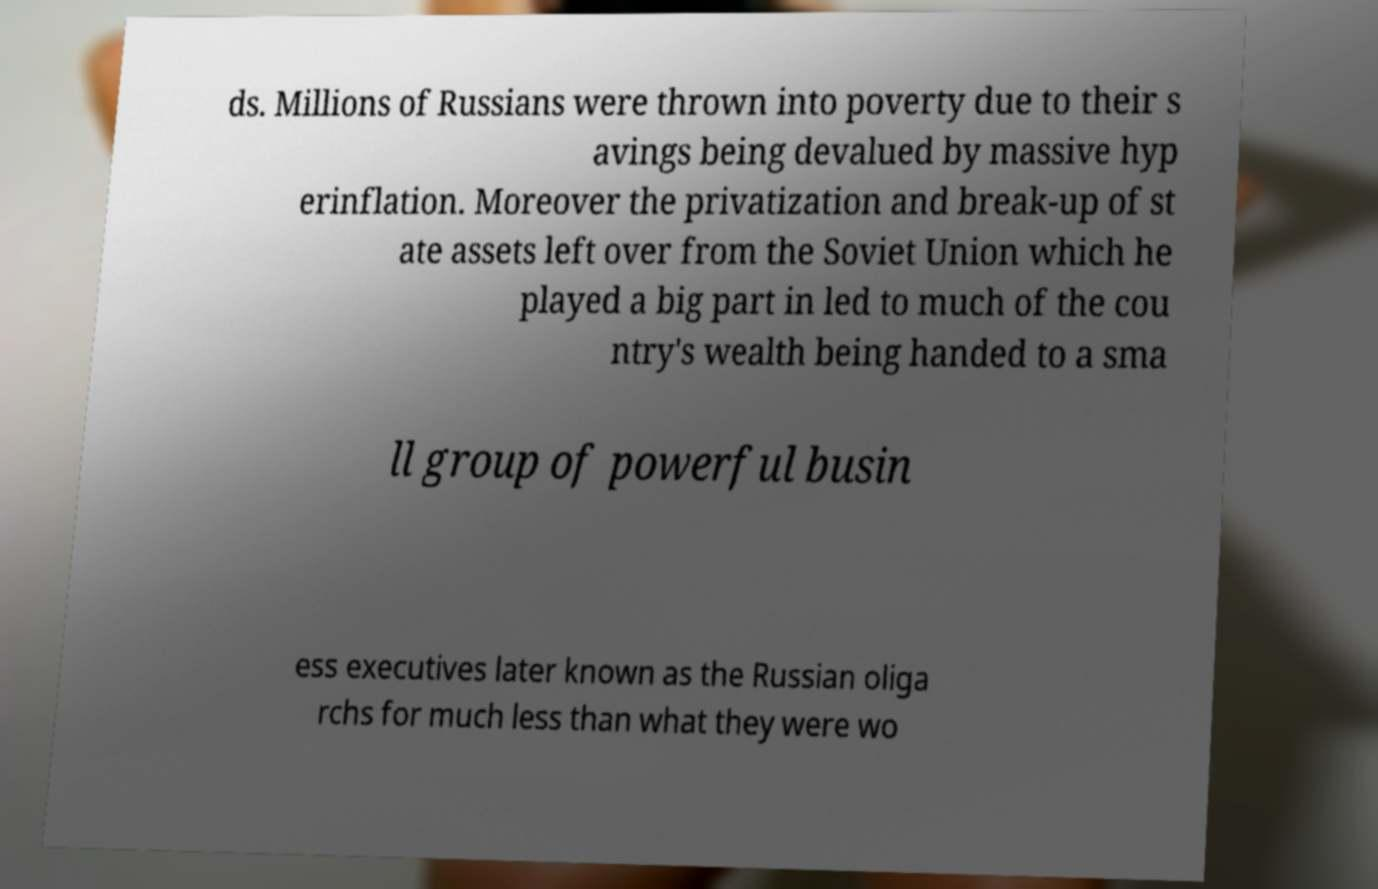I need the written content from this picture converted into text. Can you do that? ds. Millions of Russians were thrown into poverty due to their s avings being devalued by massive hyp erinflation. Moreover the privatization and break-up of st ate assets left over from the Soviet Union which he played a big part in led to much of the cou ntry's wealth being handed to a sma ll group of powerful busin ess executives later known as the Russian oliga rchs for much less than what they were wo 